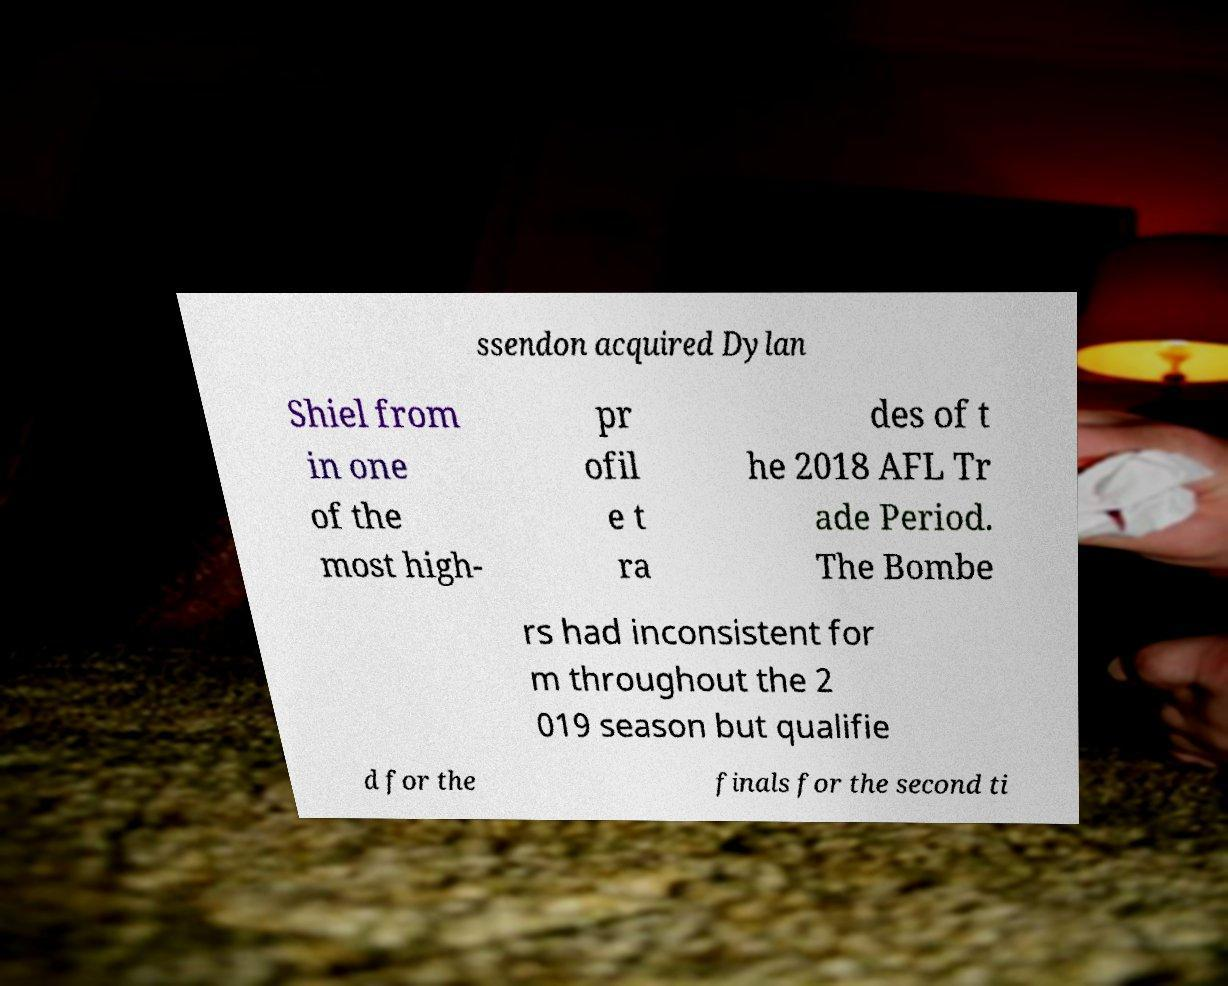What messages or text are displayed in this image? I need them in a readable, typed format. ssendon acquired Dylan Shiel from in one of the most high- pr ofil e t ra des of t he 2018 AFL Tr ade Period. The Bombe rs had inconsistent for m throughout the 2 019 season but qualifie d for the finals for the second ti 